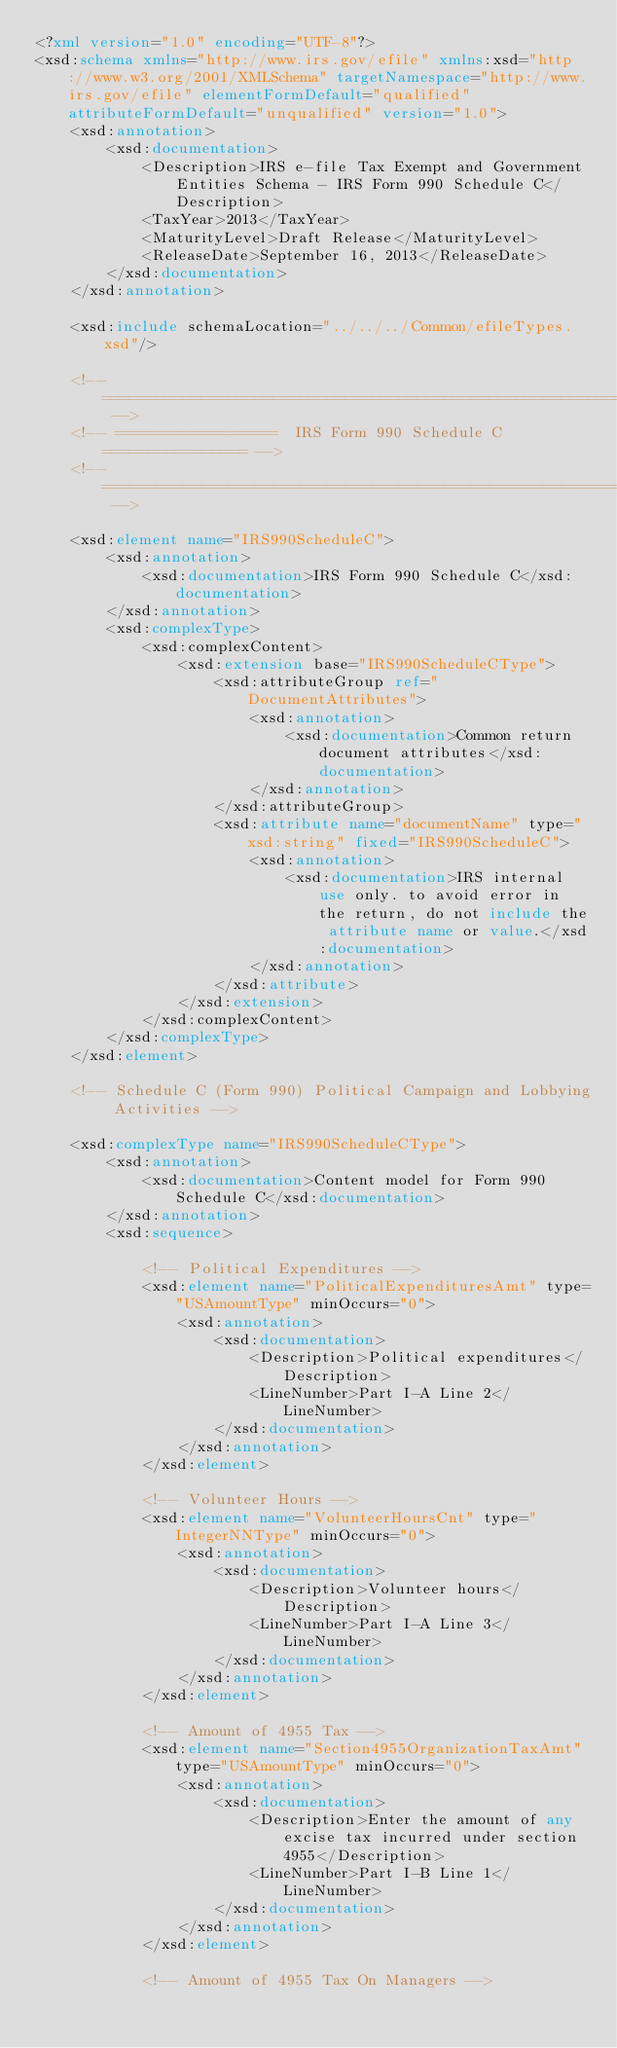Convert code to text. <code><loc_0><loc_0><loc_500><loc_500><_XML_><?xml version="1.0" encoding="UTF-8"?>
<xsd:schema xmlns="http://www.irs.gov/efile" xmlns:xsd="http://www.w3.org/2001/XMLSchema" targetNamespace="http://www.irs.gov/efile" elementFormDefault="qualified" attributeFormDefault="unqualified" version="1.0">
	<xsd:annotation>
		<xsd:documentation>
			<Description>IRS e-file Tax Exempt and Government Entities Schema - IRS Form 990 Schedule C</Description>
			<TaxYear>2013</TaxYear>
			<MaturityLevel>Draft Release</MaturityLevel>
			<ReleaseDate>September 16, 2013</ReleaseDate>
		</xsd:documentation>
	</xsd:annotation>

	<xsd:include schemaLocation="../../../Common/efileTypes.xsd"/>
	
	<!-- ====================================================================== -->
	<!-- ==================  IRS Form 990 Schedule C ================ -->
	<!-- ====================================================================== -->
	
	<xsd:element name="IRS990ScheduleC">
		<xsd:annotation>
			<xsd:documentation>IRS Form 990 Schedule C</xsd:documentation>
		</xsd:annotation>
		<xsd:complexType>
			<xsd:complexContent>
				<xsd:extension base="IRS990ScheduleCType">
					<xsd:attributeGroup ref="DocumentAttributes">
						<xsd:annotation>
							<xsd:documentation>Common return document attributes</xsd:documentation>
						</xsd:annotation>
					</xsd:attributeGroup>
					<xsd:attribute name="documentName" type="xsd:string" fixed="IRS990ScheduleC">
						<xsd:annotation>
							<xsd:documentation>IRS internal use only. to avoid error in the return, do not include the attribute name or value.</xsd:documentation>
						</xsd:annotation>
					</xsd:attribute>
				</xsd:extension>
			</xsd:complexContent>
		</xsd:complexType>
	</xsd:element>
	
	<!-- Schedule C (Form 990) Political Campaign and Lobbying Activities -->

	<xsd:complexType name="IRS990ScheduleCType">
		<xsd:annotation>
			<xsd:documentation>Content model for Form 990 Schedule C</xsd:documentation>
		</xsd:annotation>
		<xsd:sequence>

			<!-- Political Expenditures -->			
			<xsd:element name="PoliticalExpendituresAmt" type="USAmountType" minOccurs="0">			
				<xsd:annotation>		
					<xsd:documentation>	
						<Description>Political expenditures</Description>
						<LineNumber>Part I-A Line 2</LineNumber>
					</xsd:documentation>	
				</xsd:annotation>		
			</xsd:element>

			<!-- Volunteer Hours -->			
			<xsd:element name="VolunteerHoursCnt" type="IntegerNNType" minOccurs="0">			
				<xsd:annotation>		
					<xsd:documentation>	
						<Description>Volunteer hours</Description>
						<LineNumber>Part I-A Line 3</LineNumber>
					</xsd:documentation>	
				</xsd:annotation>		
			</xsd:element>

			<!-- Amount of 4955 Tax -->			
			<xsd:element name="Section4955OrganizationTaxAmt" type="USAmountType" minOccurs="0">			
				<xsd:annotation>		
					<xsd:documentation>	
						<Description>Enter the amount of any excise tax incurred under section 4955</Description>
						<LineNumber>Part I-B Line 1</LineNumber>
					</xsd:documentation>	
				</xsd:annotation>		
			</xsd:element>

			<!-- Amount of 4955 Tax On Managers -->			</code> 